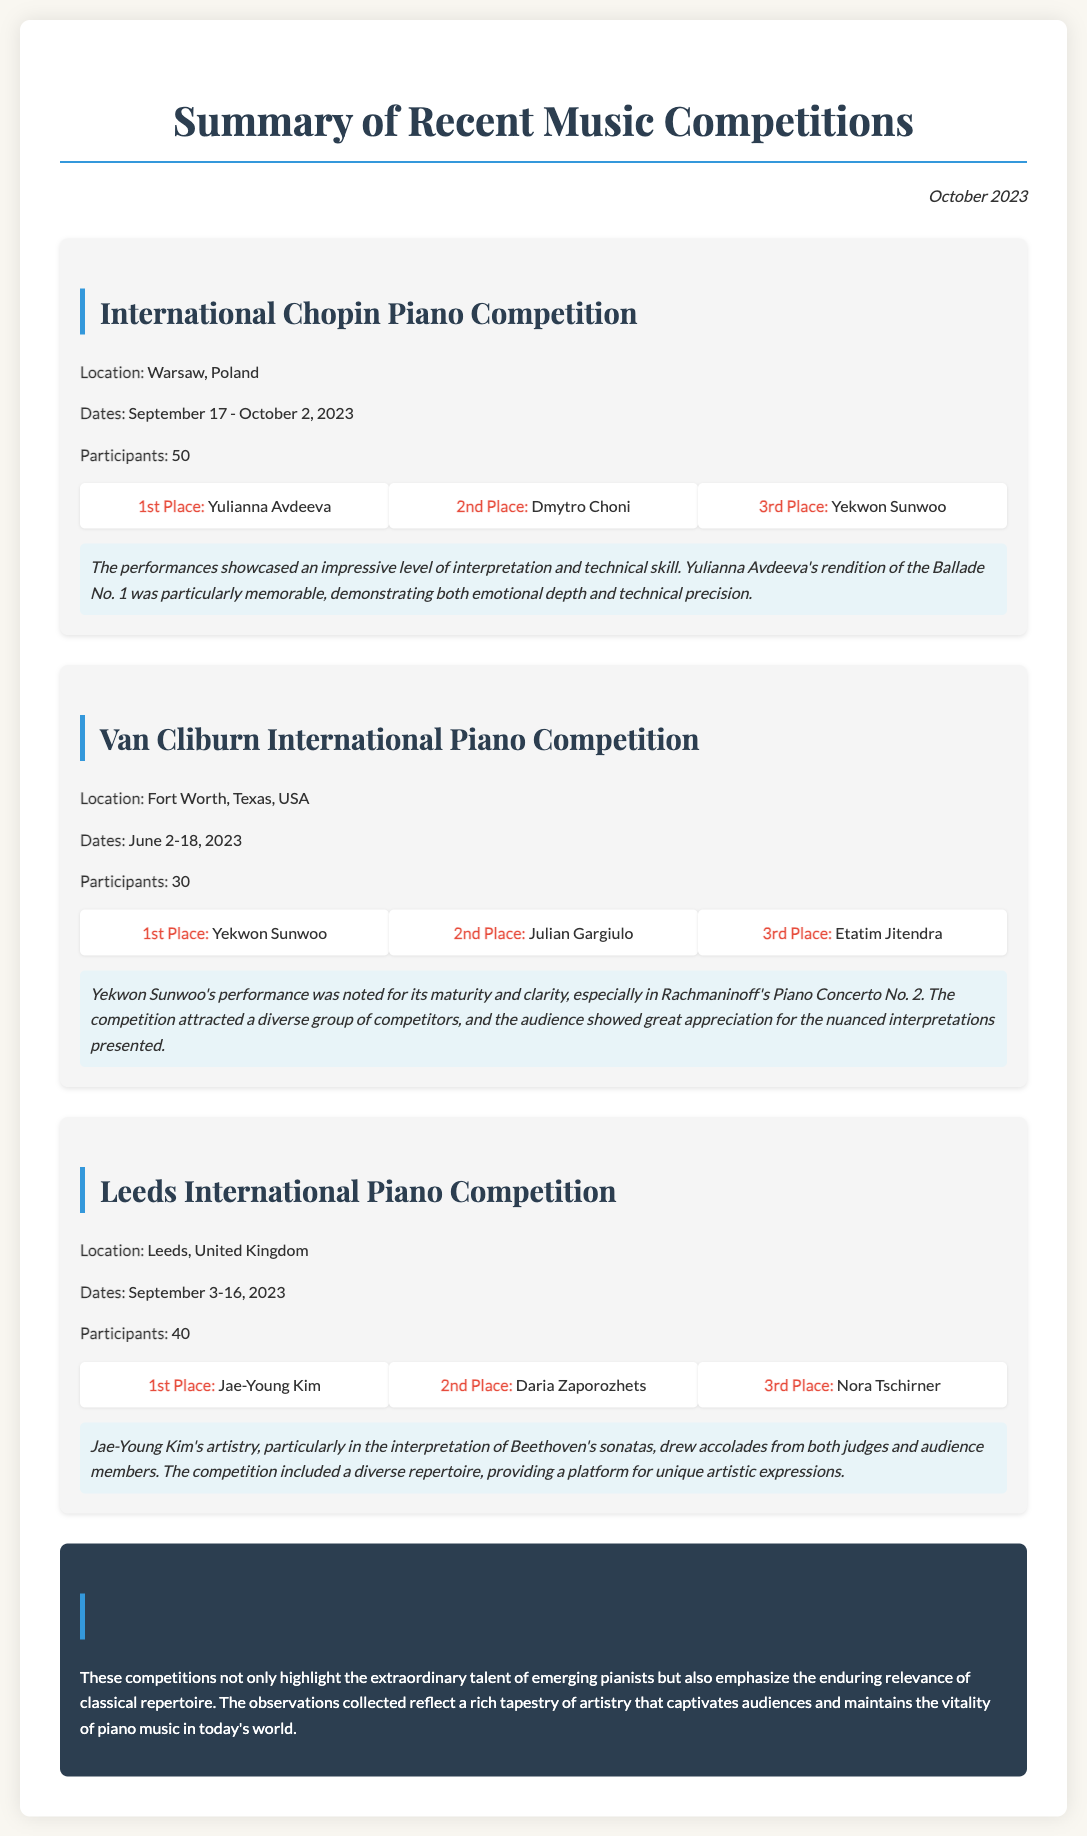what was the location of the International Chopin Piano Competition? The location listed for the International Chopin Piano Competition is Warsaw, Poland.
Answer: Warsaw, Poland who won 2nd place in the Leeds International Piano Competition? The person who secured 2nd place in the Leeds International Piano Competition is Daria Zaporozhets.
Answer: Daria Zaporozhets how many participants were in the Van Cliburn International Piano Competition? The total number of participants in the Van Cliburn International Piano Competition was 30.
Answer: 30 which competition took place in October 2023? The competition that occurred in October 2023 is the International Chopin Piano Competition.
Answer: International Chopin Piano Competition what notable performance did Yulianna Avdeeva present at the International Chopin Piano Competition? Yulianna Avdeeva's notable performance was her rendition of the Ballade No. 1.
Answer: Ballade No. 1 who had a memorable performance in Rachmaninoff's Piano Concerto No. 2? The memorable performance in Rachmaninoff's Piano Concerto No. 2 was by Yekwon Sunwoo.
Answer: Yekwon Sunwoo what was a common theme in the observations across the competitions? The observations across the competitions emphasized the extraordinary talent and artistry of the pianists.
Answer: extraordinary talent and artistry what was the conclusion regarding classical repertoire? The conclusion reflected that classical repertoire maintains its enduring relevance.
Answer: enduring relevance 